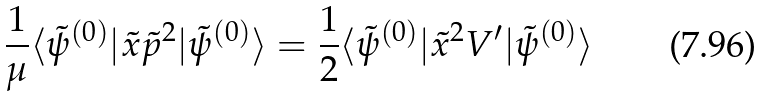Convert formula to latex. <formula><loc_0><loc_0><loc_500><loc_500>\frac { 1 } { \mu } \langle \tilde { \psi } ^ { ( 0 ) } | \tilde { x } \tilde { p } ^ { 2 } | \tilde { \psi } ^ { ( 0 ) } \rangle = \frac { 1 } { 2 } \langle \tilde { \psi } ^ { ( 0 ) } | \tilde { x } ^ { 2 } V ^ { \prime } | \tilde { \psi } ^ { ( 0 ) } \rangle</formula> 